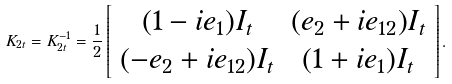<formula> <loc_0><loc_0><loc_500><loc_500>K _ { 2 t } = K _ { 2 t } ^ { - 1 } = \frac { 1 } { 2 } \left [ \begin{array} { c c } ( 1 - i e _ { 1 } ) I _ { t } & ( e _ { 2 } + i e _ { 1 2 } ) I _ { t } \\ ( - e _ { 2 } + i e _ { 1 2 } ) I _ { t } & ( 1 + i e _ { 1 } ) I _ { t } \end{array} \right ] .</formula> 